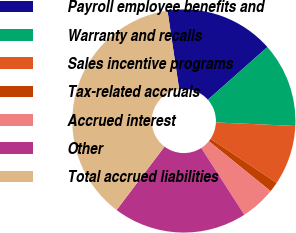Convert chart to OTSL. <chart><loc_0><loc_0><loc_500><loc_500><pie_chart><fcel>Payroll employee benefits and<fcel>Warranty and recalls<fcel>Sales incentive programs<fcel>Tax-related accruals<fcel>Accrued interest<fcel>Other<fcel>Total accrued liabilities<nl><fcel>15.82%<fcel>12.23%<fcel>8.65%<fcel>1.47%<fcel>5.06%<fcel>19.41%<fcel>37.36%<nl></chart> 